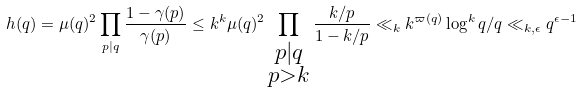Convert formula to latex. <formula><loc_0><loc_0><loc_500><loc_500>h ( q ) = \mu ( q ) ^ { 2 } \prod _ { p | q } \frac { 1 - \gamma ( p ) } { \gamma ( p ) } \leq k ^ { k } \mu ( q ) ^ { 2 } \prod _ { \substack { p | q \\ p > k } } \frac { k / p } { 1 - k / p } \ll _ { k } k ^ { \varpi ( q ) } \log ^ { k } q / q \ll _ { k , \epsilon } q ^ { \epsilon - 1 }</formula> 